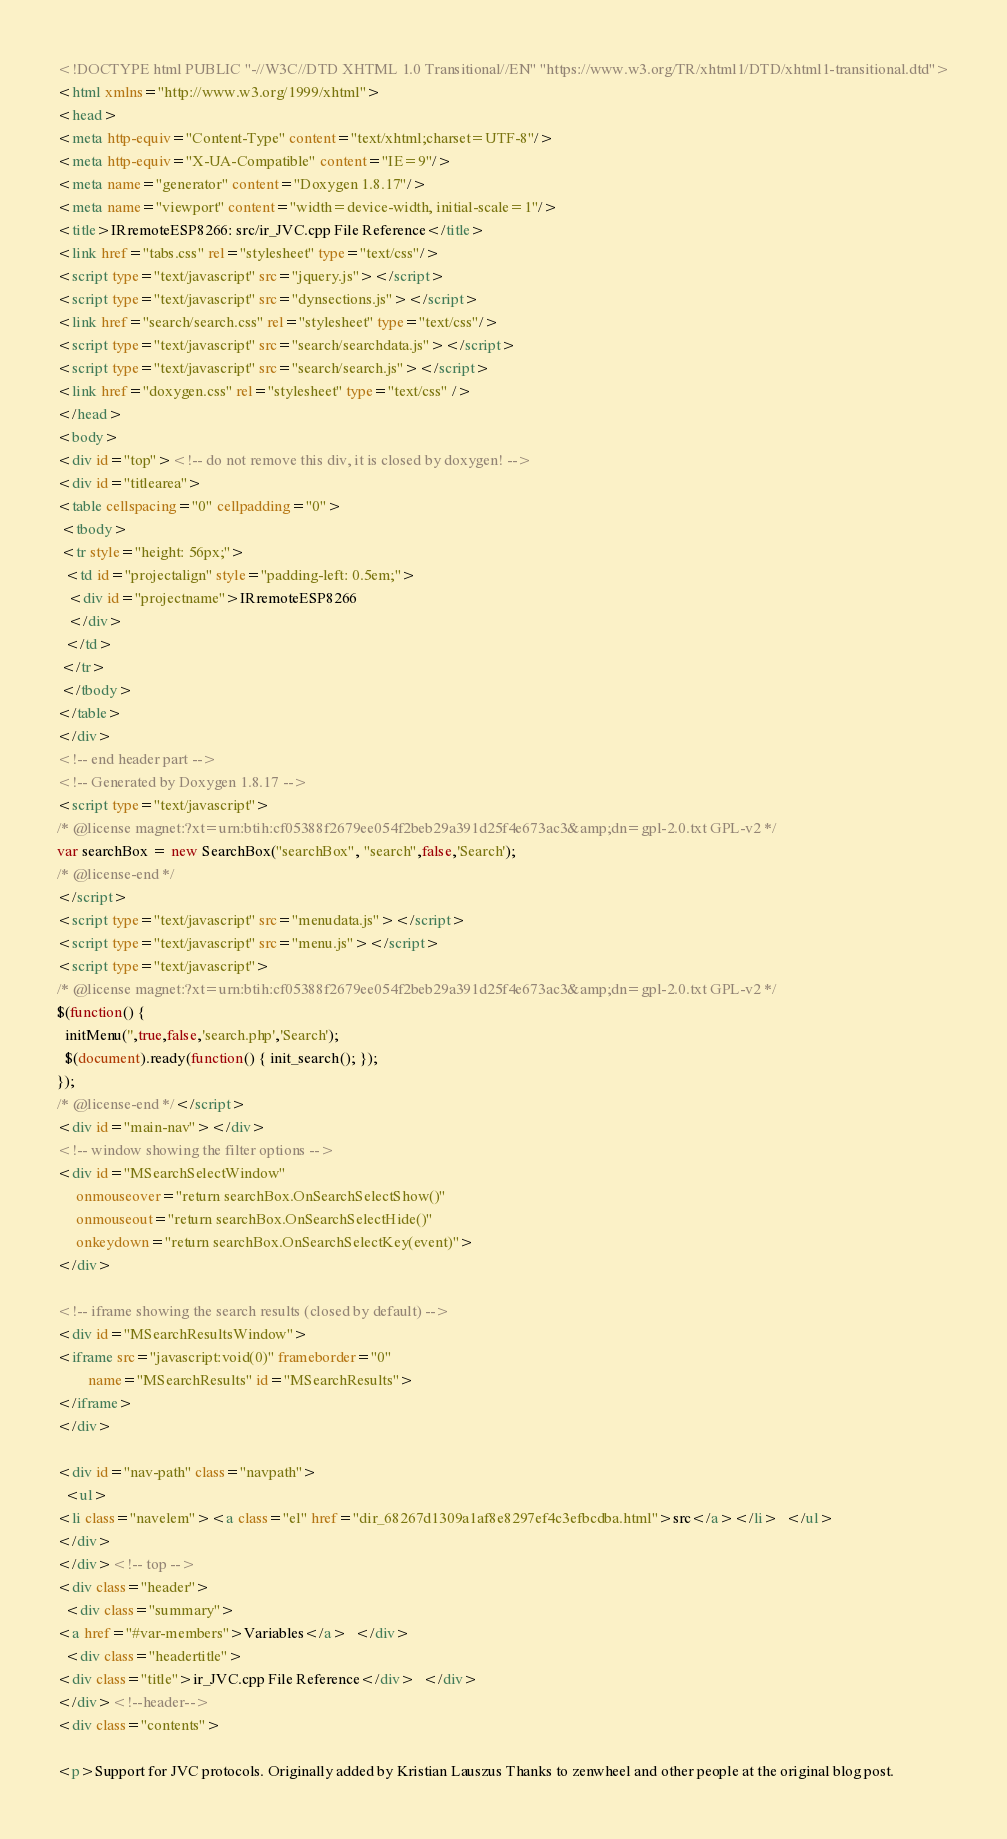<code> <loc_0><loc_0><loc_500><loc_500><_HTML_><!DOCTYPE html PUBLIC "-//W3C//DTD XHTML 1.0 Transitional//EN" "https://www.w3.org/TR/xhtml1/DTD/xhtml1-transitional.dtd">
<html xmlns="http://www.w3.org/1999/xhtml">
<head>
<meta http-equiv="Content-Type" content="text/xhtml;charset=UTF-8"/>
<meta http-equiv="X-UA-Compatible" content="IE=9"/>
<meta name="generator" content="Doxygen 1.8.17"/>
<meta name="viewport" content="width=device-width, initial-scale=1"/>
<title>IRremoteESP8266: src/ir_JVC.cpp File Reference</title>
<link href="tabs.css" rel="stylesheet" type="text/css"/>
<script type="text/javascript" src="jquery.js"></script>
<script type="text/javascript" src="dynsections.js"></script>
<link href="search/search.css" rel="stylesheet" type="text/css"/>
<script type="text/javascript" src="search/searchdata.js"></script>
<script type="text/javascript" src="search/search.js"></script>
<link href="doxygen.css" rel="stylesheet" type="text/css" />
</head>
<body>
<div id="top"><!-- do not remove this div, it is closed by doxygen! -->
<div id="titlearea">
<table cellspacing="0" cellpadding="0">
 <tbody>
 <tr style="height: 56px;">
  <td id="projectalign" style="padding-left: 0.5em;">
   <div id="projectname">IRremoteESP8266
   </div>
  </td>
 </tr>
 </tbody>
</table>
</div>
<!-- end header part -->
<!-- Generated by Doxygen 1.8.17 -->
<script type="text/javascript">
/* @license magnet:?xt=urn:btih:cf05388f2679ee054f2beb29a391d25f4e673ac3&amp;dn=gpl-2.0.txt GPL-v2 */
var searchBox = new SearchBox("searchBox", "search",false,'Search');
/* @license-end */
</script>
<script type="text/javascript" src="menudata.js"></script>
<script type="text/javascript" src="menu.js"></script>
<script type="text/javascript">
/* @license magnet:?xt=urn:btih:cf05388f2679ee054f2beb29a391d25f4e673ac3&amp;dn=gpl-2.0.txt GPL-v2 */
$(function() {
  initMenu('',true,false,'search.php','Search');
  $(document).ready(function() { init_search(); });
});
/* @license-end */</script>
<div id="main-nav"></div>
<!-- window showing the filter options -->
<div id="MSearchSelectWindow"
     onmouseover="return searchBox.OnSearchSelectShow()"
     onmouseout="return searchBox.OnSearchSelectHide()"
     onkeydown="return searchBox.OnSearchSelectKey(event)">
</div>

<!-- iframe showing the search results (closed by default) -->
<div id="MSearchResultsWindow">
<iframe src="javascript:void(0)" frameborder="0" 
        name="MSearchResults" id="MSearchResults">
</iframe>
</div>

<div id="nav-path" class="navpath">
  <ul>
<li class="navelem"><a class="el" href="dir_68267d1309a1af8e8297ef4c3efbcdba.html">src</a></li>  </ul>
</div>
</div><!-- top -->
<div class="header">
  <div class="summary">
<a href="#var-members">Variables</a>  </div>
  <div class="headertitle">
<div class="title">ir_JVC.cpp File Reference</div>  </div>
</div><!--header-->
<div class="contents">

<p>Support for JVC protocols. Originally added by Kristian Lauszus Thanks to zenwheel and other people at the original blog post.  </code> 